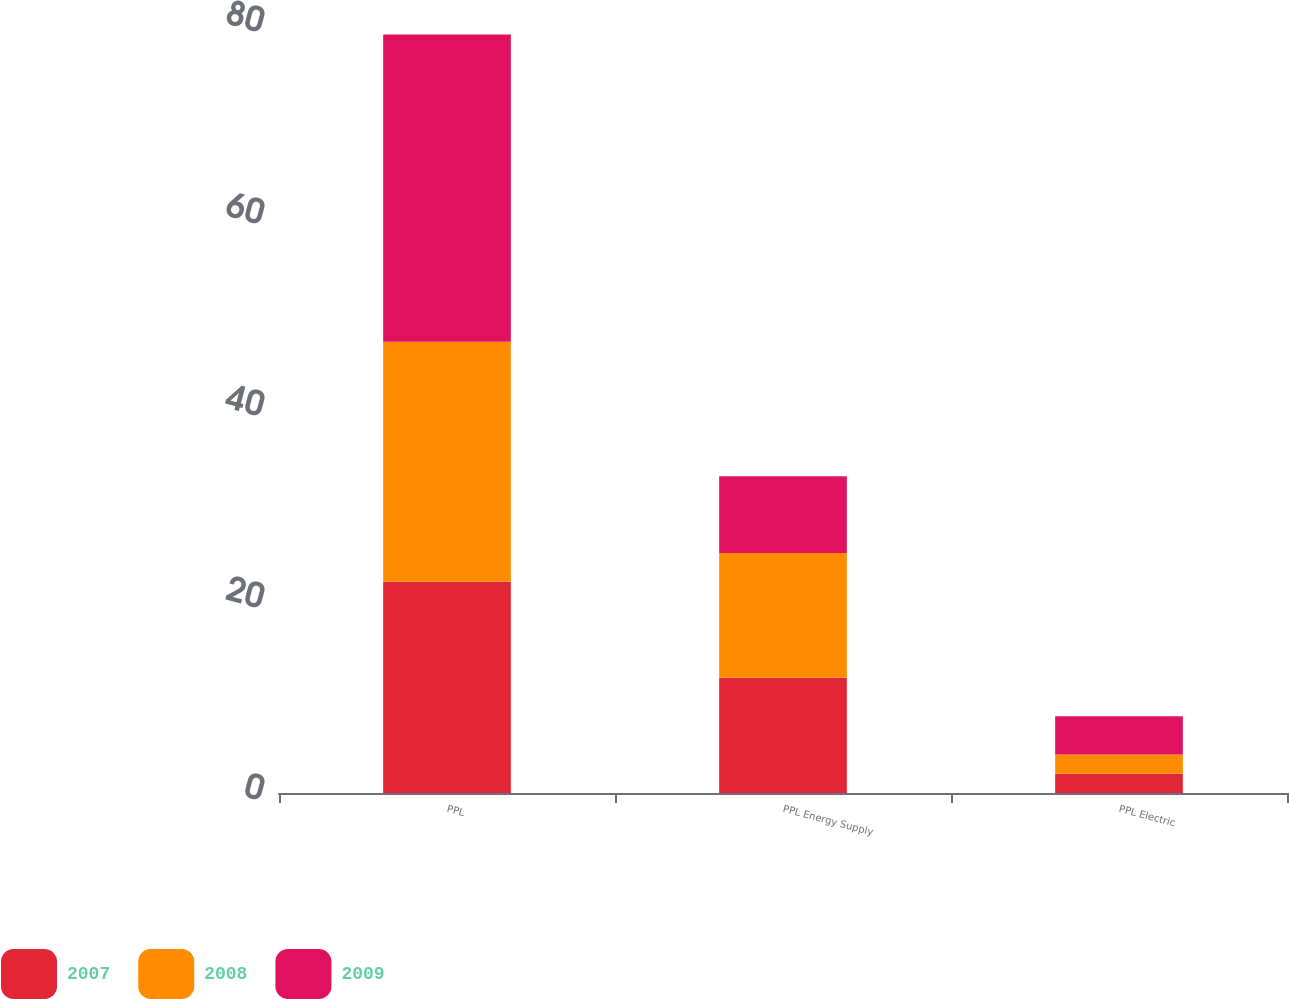<chart> <loc_0><loc_0><loc_500><loc_500><stacked_bar_chart><ecel><fcel>PPL<fcel>PPL Energy Supply<fcel>PPL Electric<nl><fcel>2007<fcel>22<fcel>12<fcel>2<nl><fcel>2008<fcel>25<fcel>13<fcel>2<nl><fcel>2009<fcel>32<fcel>8<fcel>4<nl></chart> 